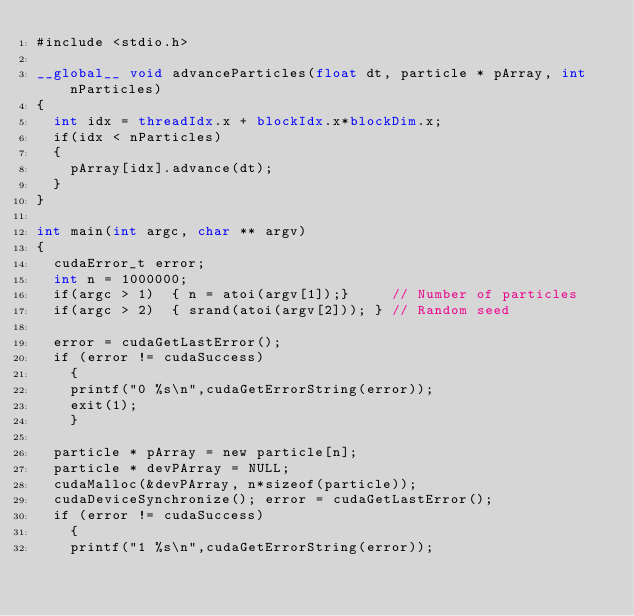<code> <loc_0><loc_0><loc_500><loc_500><_Cuda_>#include <stdio.h>

__global__ void advanceParticles(float dt, particle * pArray, int nParticles)
{
	int idx = threadIdx.x + blockIdx.x*blockDim.x;
	if(idx < nParticles)
	{
		pArray[idx].advance(dt);
	}
}

int main(int argc, char ** argv)
{
	cudaError_t error;
	int n = 1000000;
	if(argc > 1)	{ n = atoi(argv[1]);}     // Number of particles
	if(argc > 2)	{	srand(atoi(argv[2])); } // Random seed

	error = cudaGetLastError();
	if (error != cudaSuccess)
  	{
  	printf("0 %s\n",cudaGetErrorString(error));
  	exit(1);
  	}

	particle * pArray = new particle[n];
	particle * devPArray = NULL;
	cudaMalloc(&devPArray, n*sizeof(particle));
	cudaDeviceSynchronize(); error = cudaGetLastError();
	if (error != cudaSuccess)
  	{
  	printf("1 %s\n",cudaGetErrorString(error));</code> 